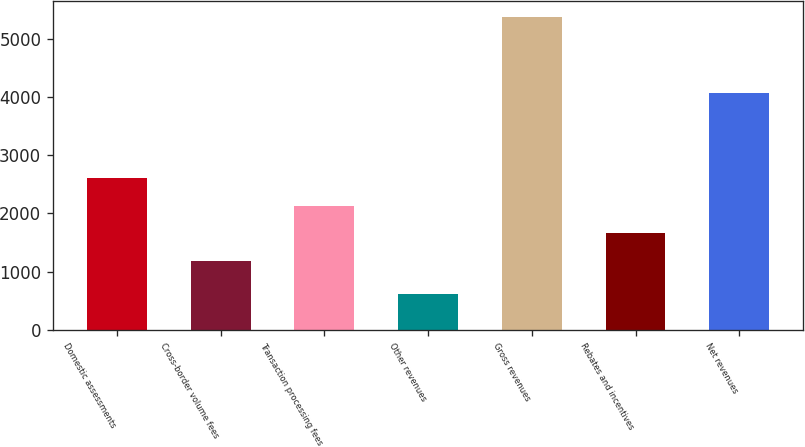<chart> <loc_0><loc_0><loc_500><loc_500><bar_chart><fcel>Domestic assessments<fcel>Cross-border volume fees<fcel>Transaction processing fees<fcel>Other revenues<fcel>Gross revenues<fcel>Rebates and incentives<fcel>Net revenues<nl><fcel>2610.7<fcel>1180<fcel>2133.8<fcel>622<fcel>5391<fcel>1656.9<fcel>4068<nl></chart> 